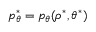<formula> <loc_0><loc_0><loc_500><loc_500>p _ { \theta } ^ { \ast } = p _ { \theta } ( \rho ^ { \ast } , \theta ^ { \ast } )</formula> 